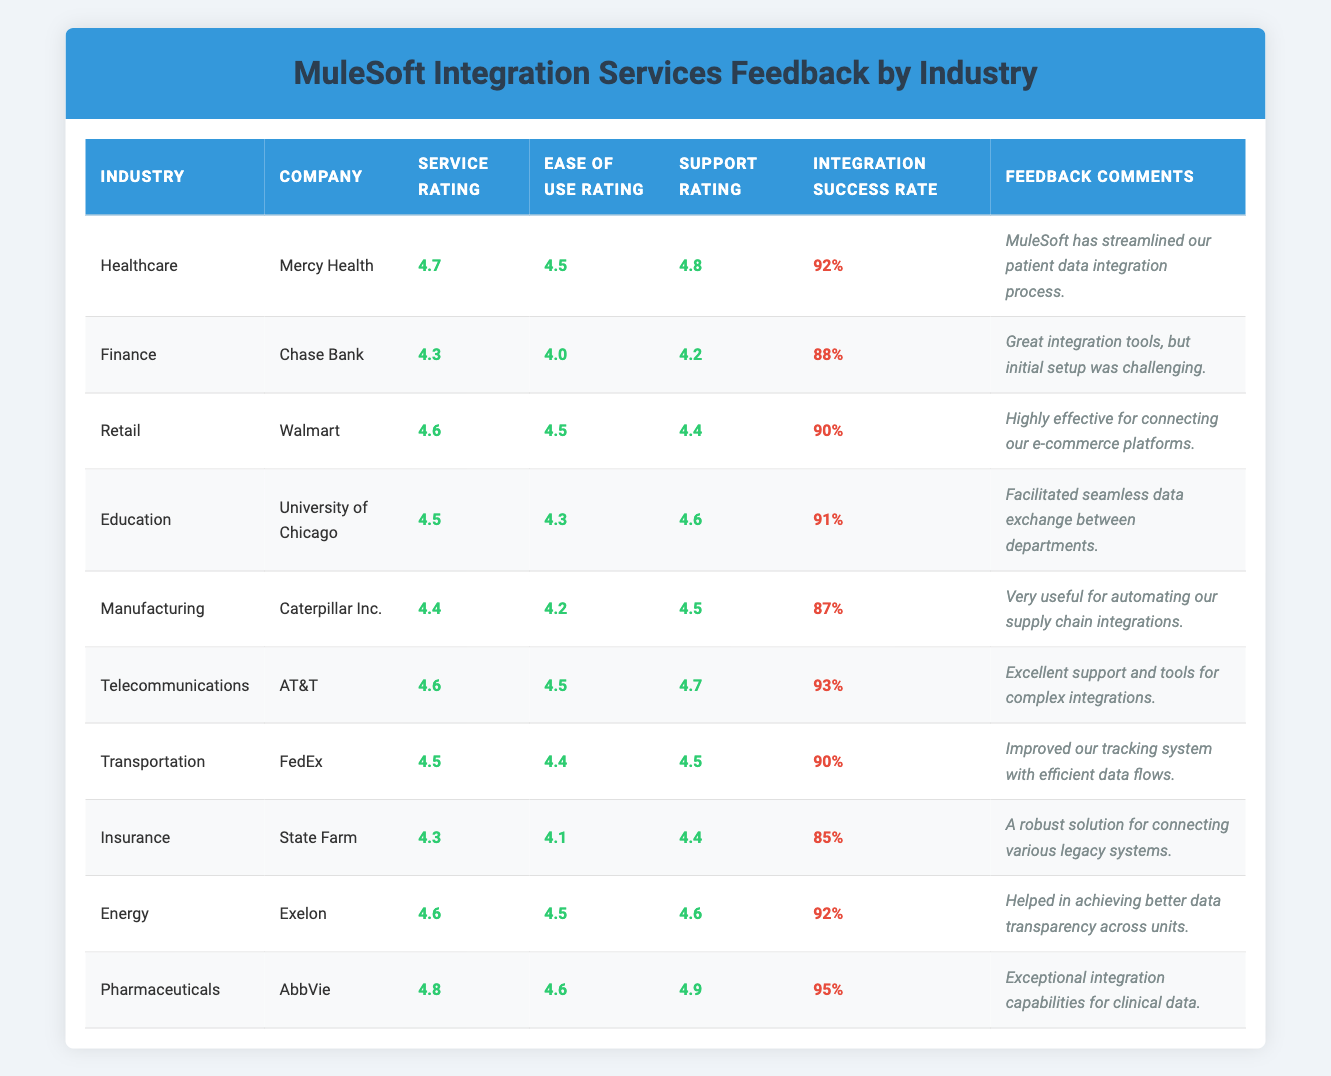What is the highest Service Rating among the companies? Looking at the Service Ratings in the table, the highest value is 4.8, which is for AbbVie in the Pharmaceuticals industry.
Answer: 4.8 Which company has the lowest Integration Success Rate? Reviewing the Integration Success Rates, State Farm is recorded with the lowest rate of 85%.
Answer: 85% What is the average Ease of Use Rating for all companies? Adding the Ease of Use Ratings: (4.5 + 4.0 + 4.5 + 4.3 + 4.2 + 4.5 + 4.4 + 4.1 + 4.5 + 4.6) = 44.3, and dividing by the number of companies (10), gives an average of 4.43.
Answer: 4.43 Does Walmart have a higher Service Rating than Chase Bank? Comparing the Service Ratings, Walmart has a rating of 4.6, and Chase Bank has 4.3, showing that Walmart's rating is indeed higher.
Answer: Yes What is the difference between the highest and lowest Support Ratings? The highest Support Rating is 4.9 (AbbVie) and the lowest is 4.1 (State Farm). The difference is 4.9 - 4.1 = 0.8.
Answer: 0.8 Which industry has the highest Integration Success Rate? Checking the Integration Success Rates for each industry, Pharmaceuticals (95%) has the highest rate among all industries.
Answer: Pharmaceuticals How many industries have an Ease of Use Rating greater than 4.4? The industries with Ease of Use Ratings greater than 4.4 are Healthcare, Retail, Telecommunications, Energy, and Pharmaceuticals, totaling 5 industries.
Answer: 5 Is the Support Rating for AT&T higher than the average Support Rating for all companies? The Support Rating for AT&T is 4.7. The average Support Rating calculated from the table is (4.8 + 4.2 + 4.4 + 4.6 + 4.5 + 4.7 + 4.5 + 4.4 + 4.6 + 4.9) = 44.6 divided by 10 equals 4.46. Since 4.7 > 4.46, the statement is true.
Answer: Yes Which company had feedback indicating they improved their tracking system? FedEx provided feedback stating they improved their tracking system with efficient data flows.
Answer: FedEx What percentage of companies have a Service Rating of 4.5 or above? Counting the companies with Service Ratings of 4.5 or above, we find 6 out of 10 companies qualify (Mercy Health, Walmart, University of Chicago, AT&T, Exelon, AbbVie). Thus the percentage is (6/10) * 100 = 60%.
Answer: 60% What was the feedback comment for Caterpillar Inc.? The feedback comment for Caterpillar Inc. is "Very useful for automating our supply chain integrations."
Answer: Very useful for automating our supply chain integrations 